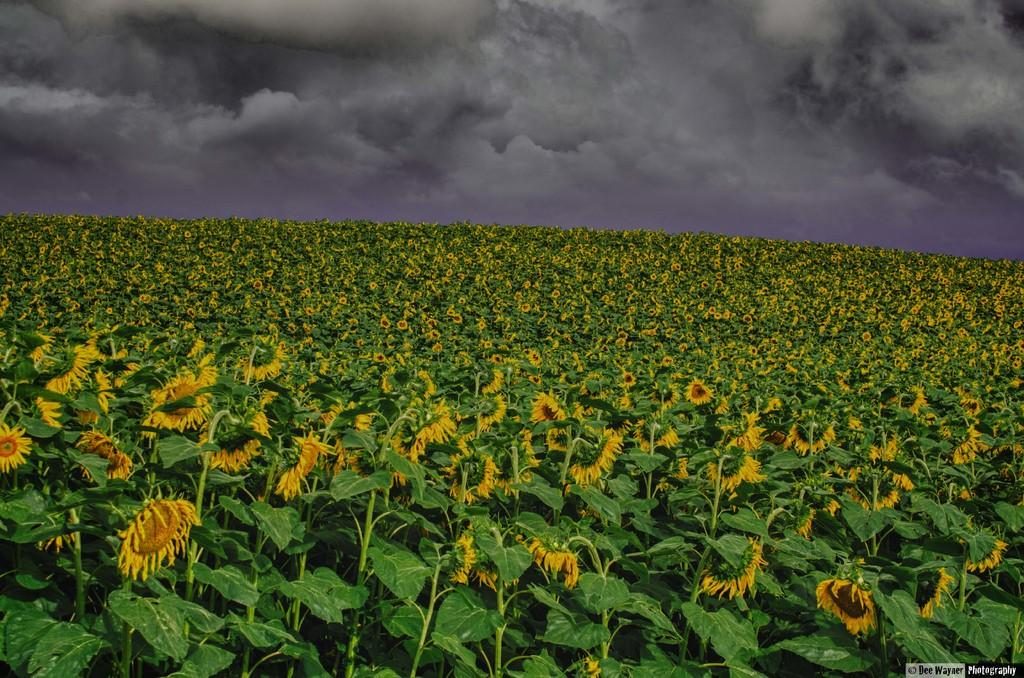What type of farm is shown in the image? There is a sunflower farm in the image. What can be seen in the background of the image? The sky is visible in the background of the image. Are there any weather conditions visible in the sky? Yes, there are clouds in the sky. How many wrens can be seen perched on the sunflowers in the image? There are no wrens present in the image; it features a sunflower farm. What type of furniture is visible among the sunflowers in the image? There is no furniture visible in the image; it features a sunflower farm. 